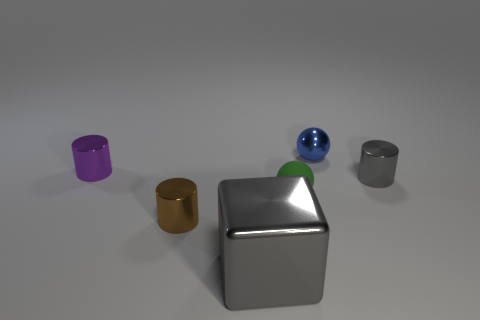Are there any other things that are the same material as the green ball?
Give a very brief answer. No. What color is the other sphere that is the same size as the green sphere?
Ensure brevity in your answer.  Blue. Are there fewer metal cylinders behind the tiny gray cylinder than brown cylinders behind the matte thing?
Keep it short and to the point. No. Do the gray shiny object behind the green thing and the small matte ball have the same size?
Your response must be concise. Yes. What is the shape of the thing behind the purple thing?
Your answer should be very brief. Sphere. Is the number of tiny metal cylinders greater than the number of tiny gray metallic things?
Keep it short and to the point. Yes. Do the small shiny thing in front of the green matte sphere and the shiny block have the same color?
Offer a terse response. No. What number of objects are either tiny cylinders that are to the right of the purple object or small metallic things that are to the left of the brown metallic cylinder?
Your response must be concise. 3. What number of tiny objects are both left of the metallic ball and behind the small brown thing?
Your answer should be very brief. 2. Does the gray block have the same material as the blue thing?
Keep it short and to the point. Yes. 